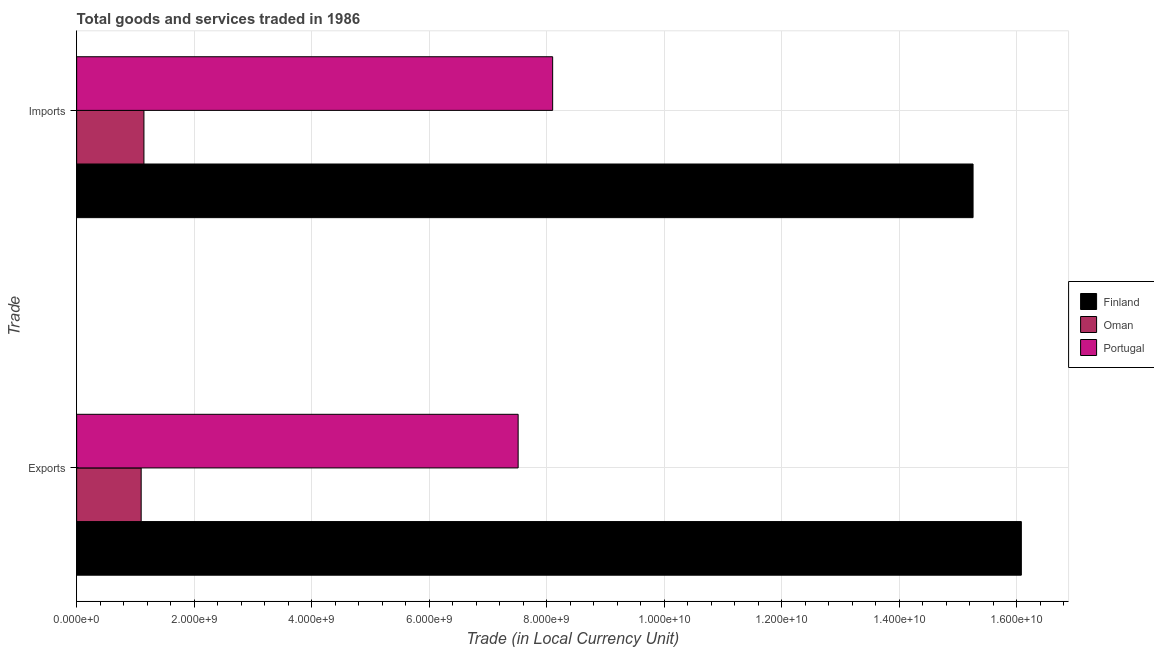Are the number of bars per tick equal to the number of legend labels?
Provide a succinct answer. Yes. How many bars are there on the 2nd tick from the top?
Provide a short and direct response. 3. How many bars are there on the 1st tick from the bottom?
Make the answer very short. 3. What is the label of the 2nd group of bars from the top?
Your answer should be compact. Exports. What is the export of goods and services in Finland?
Offer a terse response. 1.61e+1. Across all countries, what is the maximum export of goods and services?
Give a very brief answer. 1.61e+1. Across all countries, what is the minimum export of goods and services?
Ensure brevity in your answer.  1.10e+09. In which country was the imports of goods and services maximum?
Your answer should be compact. Finland. In which country was the imports of goods and services minimum?
Provide a succinct answer. Oman. What is the total imports of goods and services in the graph?
Your answer should be very brief. 2.45e+1. What is the difference between the imports of goods and services in Finland and that in Oman?
Keep it short and to the point. 1.41e+1. What is the difference between the imports of goods and services in Finland and the export of goods and services in Portugal?
Provide a short and direct response. 7.74e+09. What is the average export of goods and services per country?
Give a very brief answer. 8.23e+09. What is the difference between the export of goods and services and imports of goods and services in Portugal?
Give a very brief answer. -5.87e+08. What is the ratio of the export of goods and services in Finland to that in Portugal?
Ensure brevity in your answer.  2.14. In how many countries, is the imports of goods and services greater than the average imports of goods and services taken over all countries?
Your response must be concise. 1. What does the 2nd bar from the top in Exports represents?
Provide a succinct answer. Oman. What does the 2nd bar from the bottom in Exports represents?
Your response must be concise. Oman. How many bars are there?
Ensure brevity in your answer.  6. How many countries are there in the graph?
Your answer should be very brief. 3. What is the difference between two consecutive major ticks on the X-axis?
Ensure brevity in your answer.  2.00e+09. Are the values on the major ticks of X-axis written in scientific E-notation?
Provide a succinct answer. Yes. How are the legend labels stacked?
Ensure brevity in your answer.  Vertical. What is the title of the graph?
Offer a terse response. Total goods and services traded in 1986. Does "Macao" appear as one of the legend labels in the graph?
Provide a short and direct response. No. What is the label or title of the X-axis?
Offer a terse response. Trade (in Local Currency Unit). What is the label or title of the Y-axis?
Provide a short and direct response. Trade. What is the Trade (in Local Currency Unit) of Finland in Exports?
Your response must be concise. 1.61e+1. What is the Trade (in Local Currency Unit) of Oman in Exports?
Offer a terse response. 1.10e+09. What is the Trade (in Local Currency Unit) of Portugal in Exports?
Your response must be concise. 7.51e+09. What is the Trade (in Local Currency Unit) in Finland in Imports?
Keep it short and to the point. 1.53e+1. What is the Trade (in Local Currency Unit) of Oman in Imports?
Your answer should be compact. 1.14e+09. What is the Trade (in Local Currency Unit) in Portugal in Imports?
Make the answer very short. 8.10e+09. Across all Trade, what is the maximum Trade (in Local Currency Unit) in Finland?
Offer a very short reply. 1.61e+1. Across all Trade, what is the maximum Trade (in Local Currency Unit) in Oman?
Ensure brevity in your answer.  1.14e+09. Across all Trade, what is the maximum Trade (in Local Currency Unit) in Portugal?
Your response must be concise. 8.10e+09. Across all Trade, what is the minimum Trade (in Local Currency Unit) in Finland?
Ensure brevity in your answer.  1.53e+1. Across all Trade, what is the minimum Trade (in Local Currency Unit) in Oman?
Provide a short and direct response. 1.10e+09. Across all Trade, what is the minimum Trade (in Local Currency Unit) in Portugal?
Ensure brevity in your answer.  7.51e+09. What is the total Trade (in Local Currency Unit) in Finland in the graph?
Your answer should be very brief. 3.13e+1. What is the total Trade (in Local Currency Unit) of Oman in the graph?
Your answer should be very brief. 2.24e+09. What is the total Trade (in Local Currency Unit) of Portugal in the graph?
Your answer should be compact. 1.56e+1. What is the difference between the Trade (in Local Currency Unit) in Finland in Exports and that in Imports?
Your answer should be compact. 8.22e+08. What is the difference between the Trade (in Local Currency Unit) of Oman in Exports and that in Imports?
Your response must be concise. -4.70e+07. What is the difference between the Trade (in Local Currency Unit) of Portugal in Exports and that in Imports?
Your answer should be compact. -5.87e+08. What is the difference between the Trade (in Local Currency Unit) of Finland in Exports and the Trade (in Local Currency Unit) of Oman in Imports?
Provide a succinct answer. 1.49e+1. What is the difference between the Trade (in Local Currency Unit) of Finland in Exports and the Trade (in Local Currency Unit) of Portugal in Imports?
Your answer should be compact. 7.98e+09. What is the difference between the Trade (in Local Currency Unit) of Oman in Exports and the Trade (in Local Currency Unit) of Portugal in Imports?
Provide a short and direct response. -7.00e+09. What is the average Trade (in Local Currency Unit) of Finland per Trade?
Make the answer very short. 1.57e+1. What is the average Trade (in Local Currency Unit) in Oman per Trade?
Your answer should be very brief. 1.12e+09. What is the average Trade (in Local Currency Unit) of Portugal per Trade?
Provide a succinct answer. 7.81e+09. What is the difference between the Trade (in Local Currency Unit) of Finland and Trade (in Local Currency Unit) of Oman in Exports?
Provide a short and direct response. 1.50e+1. What is the difference between the Trade (in Local Currency Unit) of Finland and Trade (in Local Currency Unit) of Portugal in Exports?
Ensure brevity in your answer.  8.56e+09. What is the difference between the Trade (in Local Currency Unit) of Oman and Trade (in Local Currency Unit) of Portugal in Exports?
Provide a succinct answer. -6.42e+09. What is the difference between the Trade (in Local Currency Unit) in Finland and Trade (in Local Currency Unit) in Oman in Imports?
Offer a very short reply. 1.41e+1. What is the difference between the Trade (in Local Currency Unit) in Finland and Trade (in Local Currency Unit) in Portugal in Imports?
Your answer should be compact. 7.16e+09. What is the difference between the Trade (in Local Currency Unit) in Oman and Trade (in Local Currency Unit) in Portugal in Imports?
Offer a terse response. -6.96e+09. What is the ratio of the Trade (in Local Currency Unit) of Finland in Exports to that in Imports?
Your response must be concise. 1.05. What is the ratio of the Trade (in Local Currency Unit) of Oman in Exports to that in Imports?
Provide a short and direct response. 0.96. What is the ratio of the Trade (in Local Currency Unit) of Portugal in Exports to that in Imports?
Make the answer very short. 0.93. What is the difference between the highest and the second highest Trade (in Local Currency Unit) of Finland?
Offer a terse response. 8.22e+08. What is the difference between the highest and the second highest Trade (in Local Currency Unit) in Oman?
Your answer should be very brief. 4.70e+07. What is the difference between the highest and the second highest Trade (in Local Currency Unit) of Portugal?
Your response must be concise. 5.87e+08. What is the difference between the highest and the lowest Trade (in Local Currency Unit) in Finland?
Your answer should be compact. 8.22e+08. What is the difference between the highest and the lowest Trade (in Local Currency Unit) in Oman?
Your answer should be very brief. 4.70e+07. What is the difference between the highest and the lowest Trade (in Local Currency Unit) of Portugal?
Provide a succinct answer. 5.87e+08. 